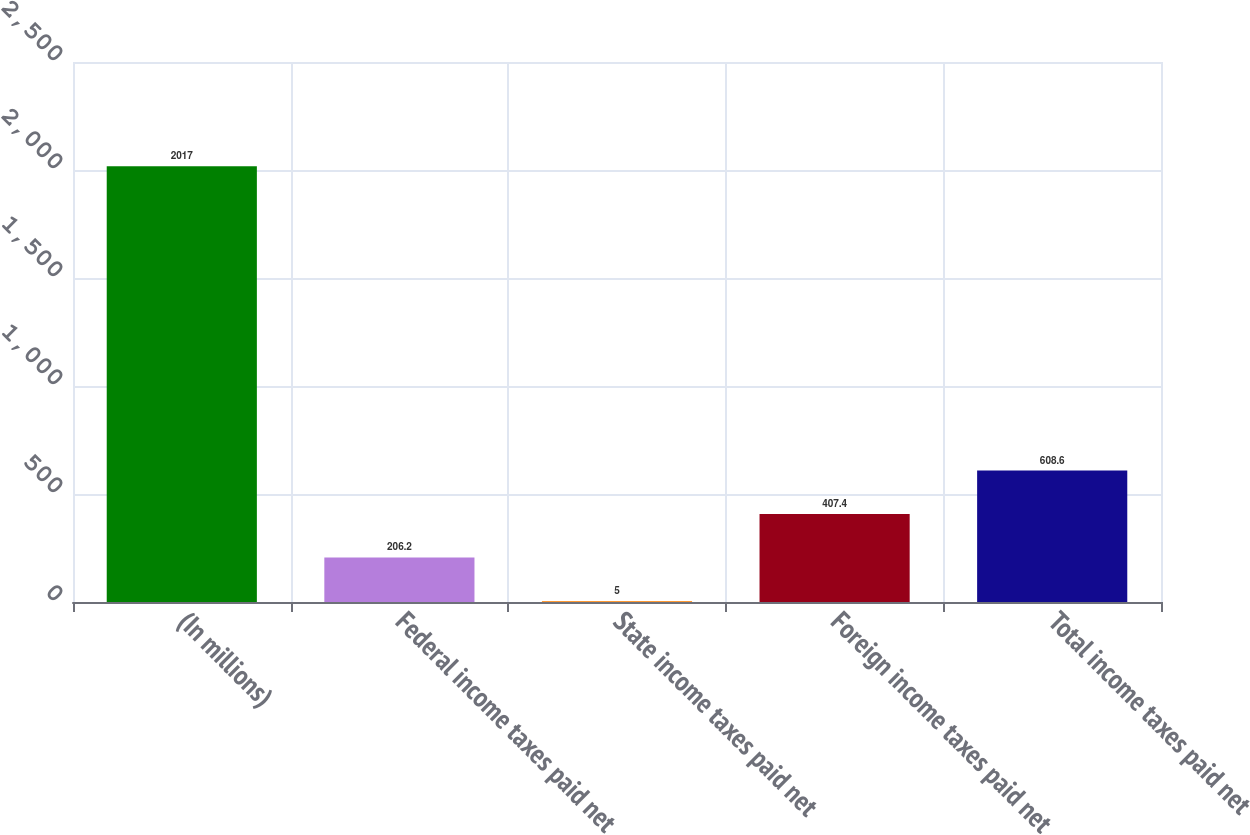Convert chart to OTSL. <chart><loc_0><loc_0><loc_500><loc_500><bar_chart><fcel>(In millions)<fcel>Federal income taxes paid net<fcel>State income taxes paid net<fcel>Foreign income taxes paid net<fcel>Total income taxes paid net<nl><fcel>2017<fcel>206.2<fcel>5<fcel>407.4<fcel>608.6<nl></chart> 